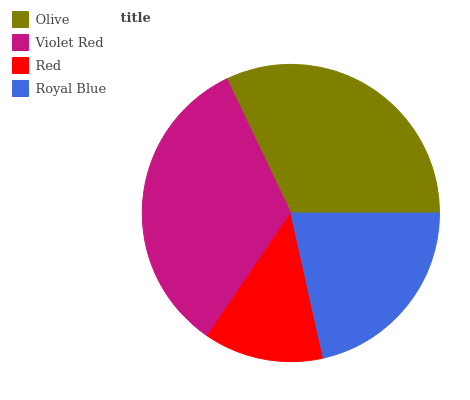Is Red the minimum?
Answer yes or no. Yes. Is Violet Red the maximum?
Answer yes or no. Yes. Is Violet Red the minimum?
Answer yes or no. No. Is Red the maximum?
Answer yes or no. No. Is Violet Red greater than Red?
Answer yes or no. Yes. Is Red less than Violet Red?
Answer yes or no. Yes. Is Red greater than Violet Red?
Answer yes or no. No. Is Violet Red less than Red?
Answer yes or no. No. Is Olive the high median?
Answer yes or no. Yes. Is Royal Blue the low median?
Answer yes or no. Yes. Is Royal Blue the high median?
Answer yes or no. No. Is Red the low median?
Answer yes or no. No. 